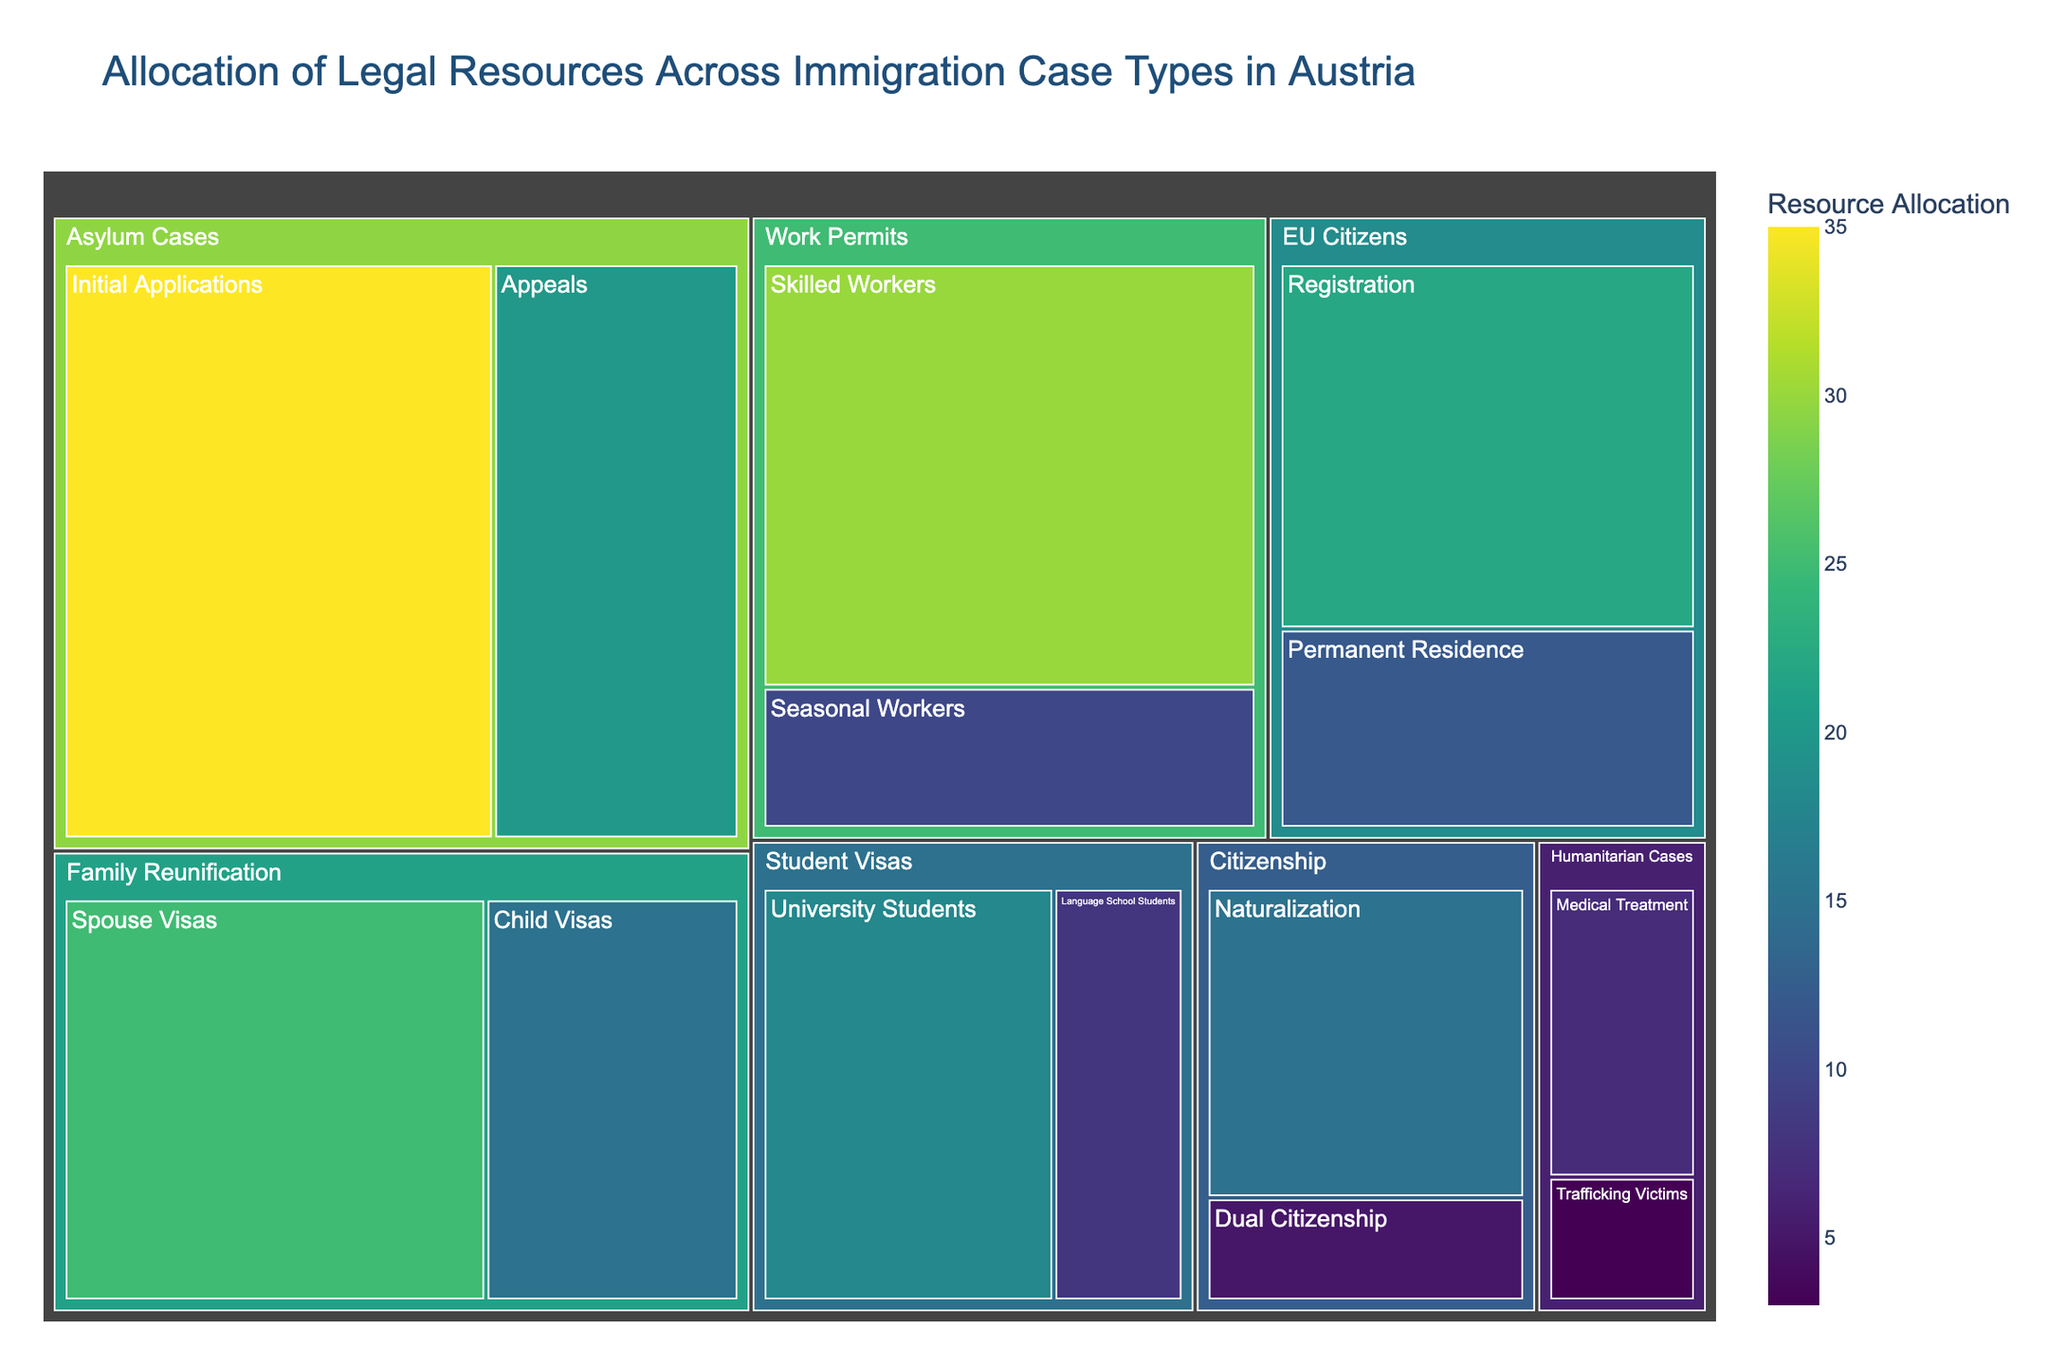What is the title of the treemap? The title is usually displayed prominently at the top of a figure. The title for this treemap is "Allocation of Legal Resources Across Immigration Case Types in Austria."
Answer: Allocation of Legal Resources Across Immigration Case Types in Austria Which subcategory under 'Asylum Cases' has the highest resource allocation? To find this, we'll look at the subcategories under 'Asylum Cases'. The subcategory 'Initial Applications' has a value of 35, while 'Appeals' has 20. 35 is greater than 20.
Answer: Initial Applications How many subcategories are there under 'Student Visas'? To determine this, we count the boxes under 'Student Visas'. The subcategories are 'University Students' and 'Language School Students', so there are 2.
Answer: 2 Which category has the lowest resource allocation, and what is its value? We identify the smallest value in the figure. 'Humanitarian Cases' has subcategories with values 7 and 3, which total 10. Since no other category or subcategory individually falls below 10, this is the lowest.
Answer: Humanitarian Cases, 10 What is the summed allocation for 'Family Reunification'? We'll sum the values for 'Spouse Visas' (25) and 'Child Visas' (15). Adding them together gives 25 + 15 = 40.
Answer: 40 Which subcategory under 'Work Permits' has a lower resource allocation and by how much? Observe the values under 'Work Permits': 'Skilled Workers' (30) and 'Seasonal Workers' (10). 10 is lower than 30. The difference is 30 - 10 = 20.
Answer: Seasonal Workers, 20 By how much does the allocation for 'University Students' exceed that for 'Language School Students'? Compare 'University Students' (18) with 'Language School Students' (8). The difference is 18 - 8 = 10.
Answer: 10 What is the combined resource allocation for all 'Citizenship' subcategories? Sum the values for 'Naturalization' (15) and 'Dual Citizenship' (5). Adding them gives 15 + 5 = 20.
Answer: 20 Which category has the highest resource allocation and what is its value? Compare the total values of all main categories. 'Asylum Cases': 35 + 20 = 55, 'Family Reunification': 40, 'Work Permits': 30 + 10 = 40, 'Student Visas': 18 + 8 = 26, 'EU Citizens': 22 + 12 = 34, 'Citizenship': 20, 'Humanitarian Cases': 10. 'Asylum Cases' has the highest value at 55.
Answer: Asylum Cases, 55 